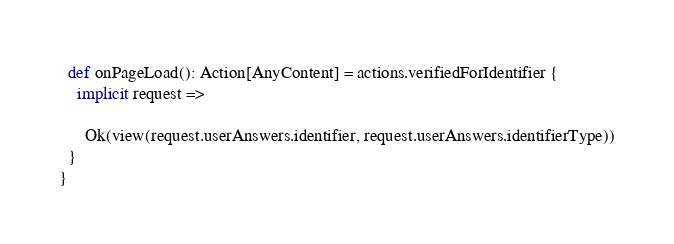<code> <loc_0><loc_0><loc_500><loc_500><_Scala_>
  def onPageLoad(): Action[AnyContent] = actions.verifiedForIdentifier {
    implicit request =>

      Ok(view(request.userAnswers.identifier, request.userAnswers.identifierType))
  }
}
</code> 